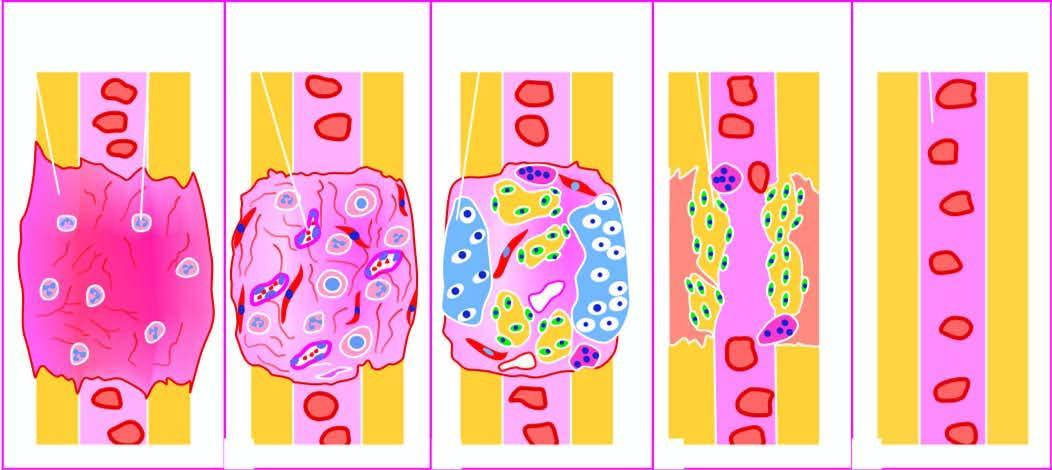s the spleen converted into lamellar bone and internal callus developing bone marrow cavity?
Answer the question using a single word or phrase. No 